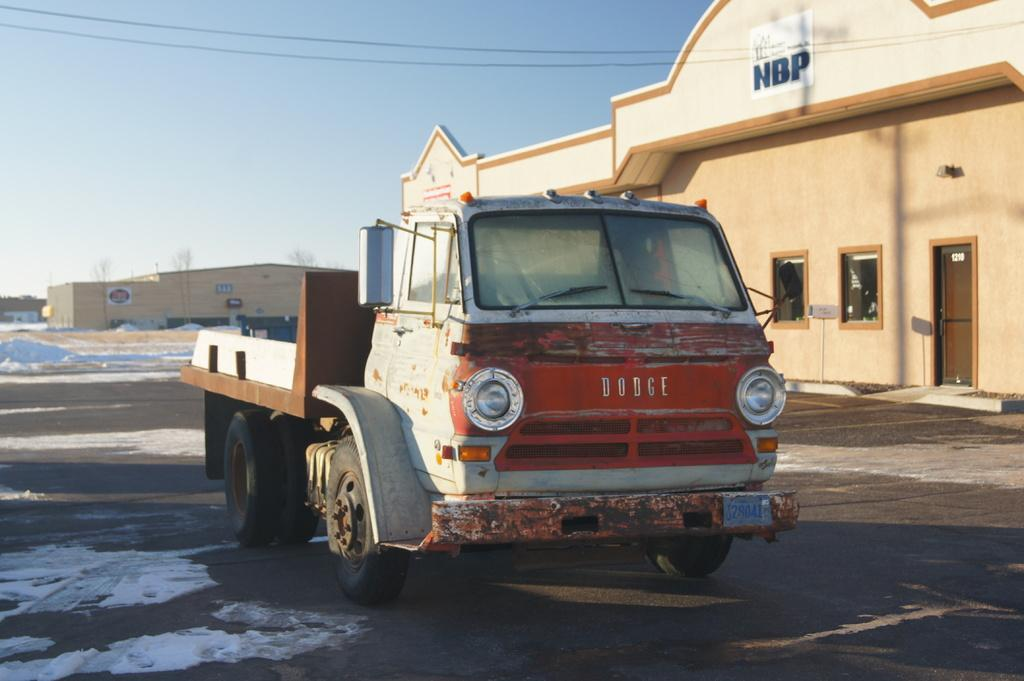What is the main subject of the image? The main subject of the image is a truck. What features can be seen on the truck? The truck has lights and mirrors. How are the mirrors positioned in the image? The mirrors are placed on the ground. What can be seen in the background of the image? There is a building with windows and the sky is visible in the background of the image. Can you describe the building in the image? The building has windows and a door. What type of island can be seen in the background of the image? There is no island present in the image; it features a truck, a building, and the sky in the background. What kind of pleasure can be experienced by the truck in the image? The image does not depict any emotions or experiences of the truck, so it is not possible to determine what kind of pleasure it might be experiencing. 